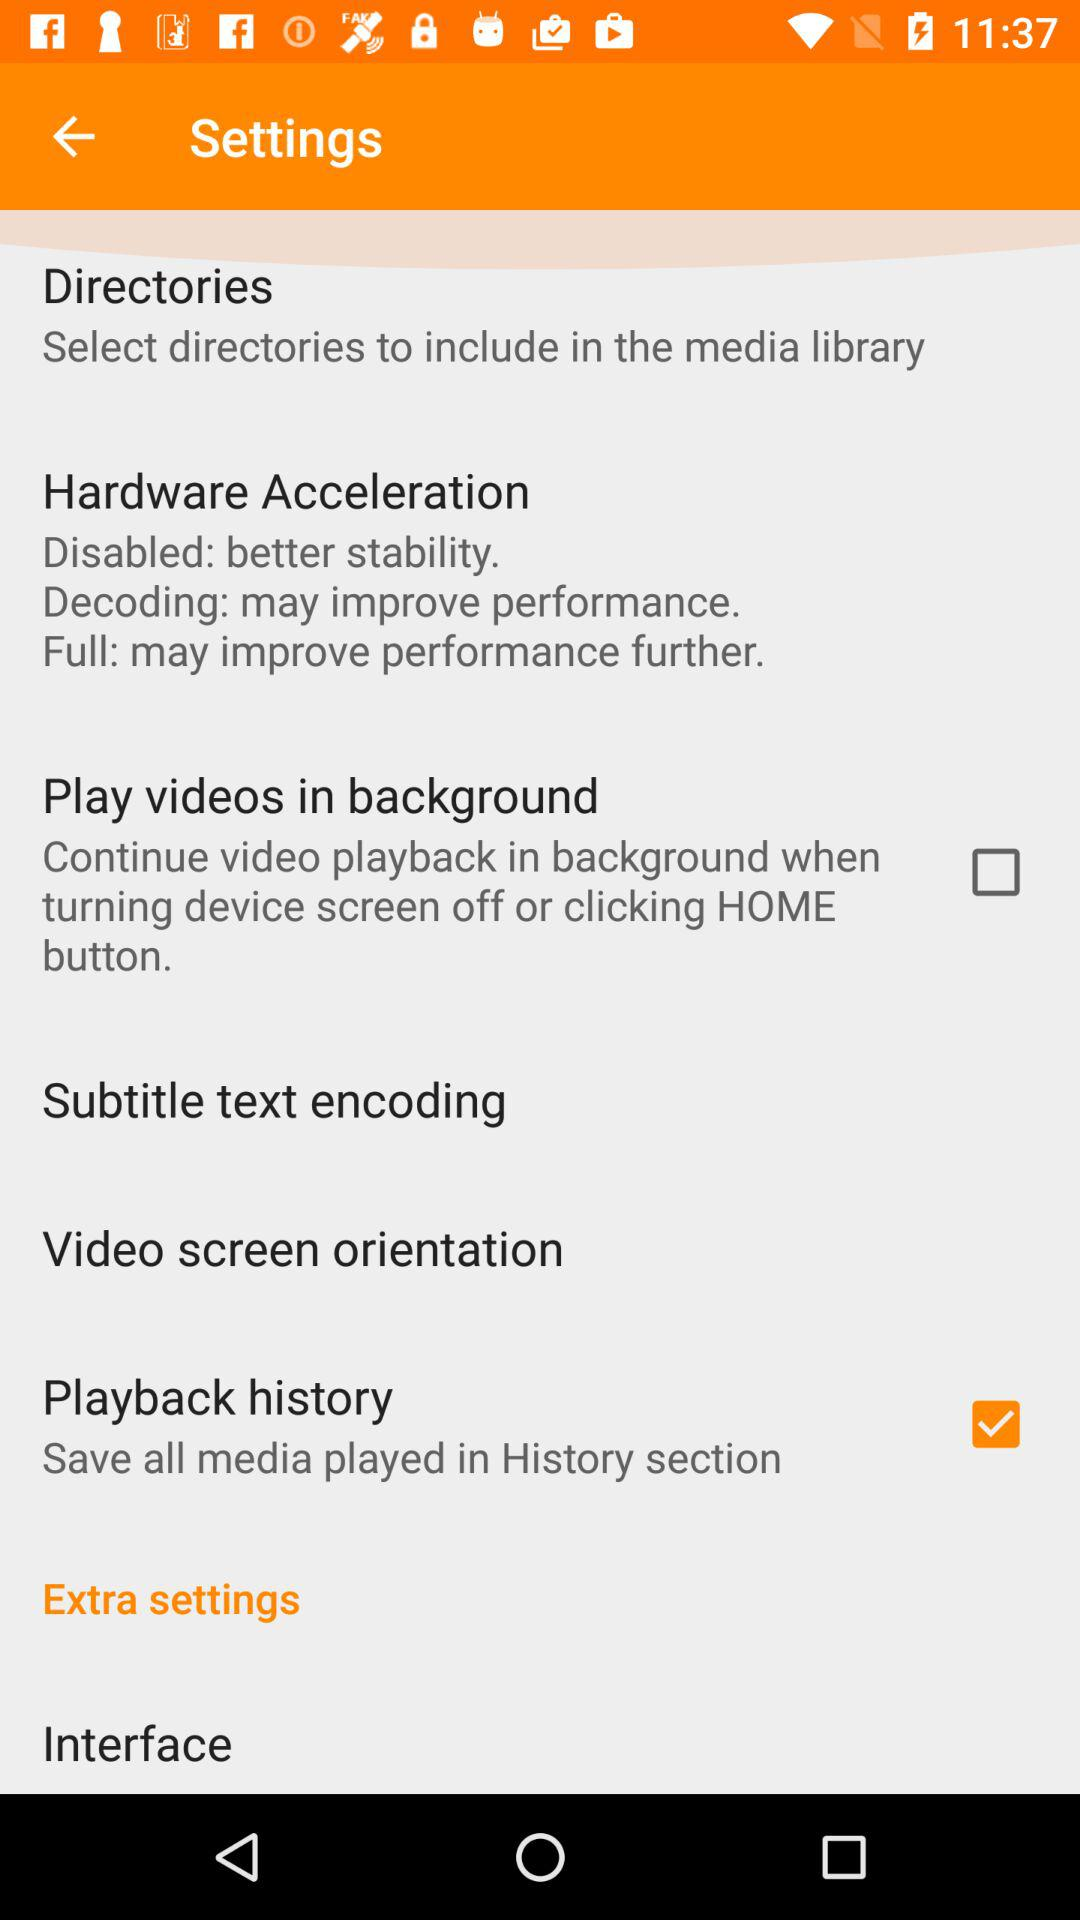How many hardware acceleration options are there?
Answer the question using a single word or phrase. 3 